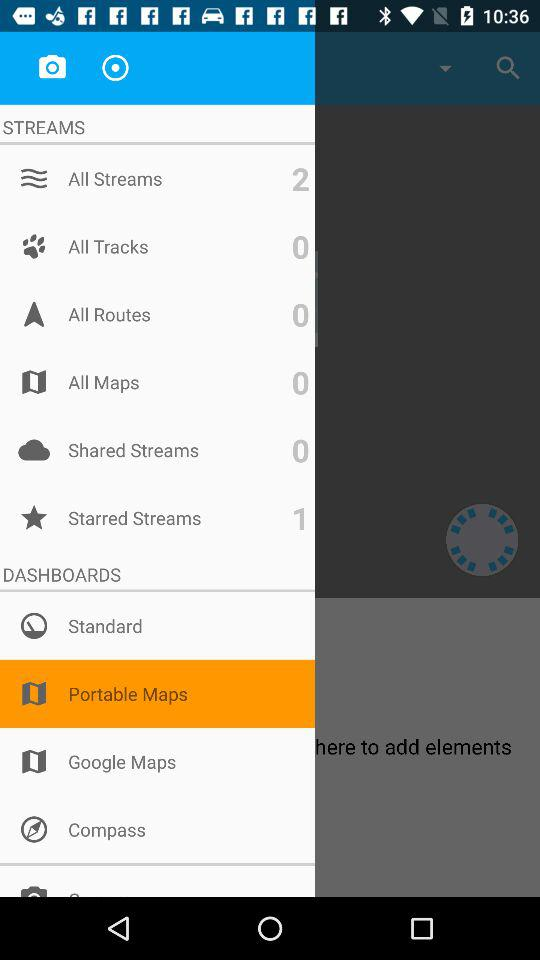How many tracks in total are there? There are 0 tracks. 